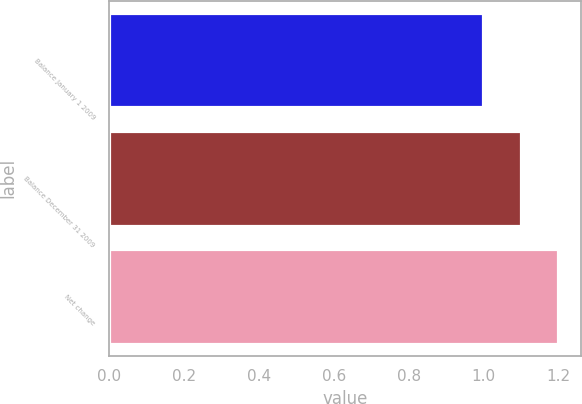Convert chart. <chart><loc_0><loc_0><loc_500><loc_500><bar_chart><fcel>Balance January 1 2009<fcel>Balance December 31 2009<fcel>Net change<nl><fcel>1<fcel>1.1<fcel>1.2<nl></chart> 